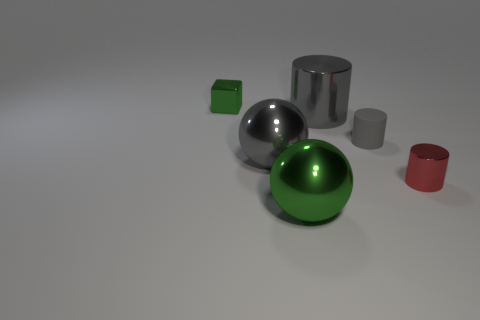Add 2 big gray metal cylinders. How many objects exist? 8 Subtract all spheres. How many objects are left? 4 Subtract all red cylinders. Subtract all gray shiny cylinders. How many objects are left? 4 Add 6 tiny gray cylinders. How many tiny gray cylinders are left? 7 Add 2 metal spheres. How many metal spheres exist? 4 Subtract 0 cyan spheres. How many objects are left? 6 